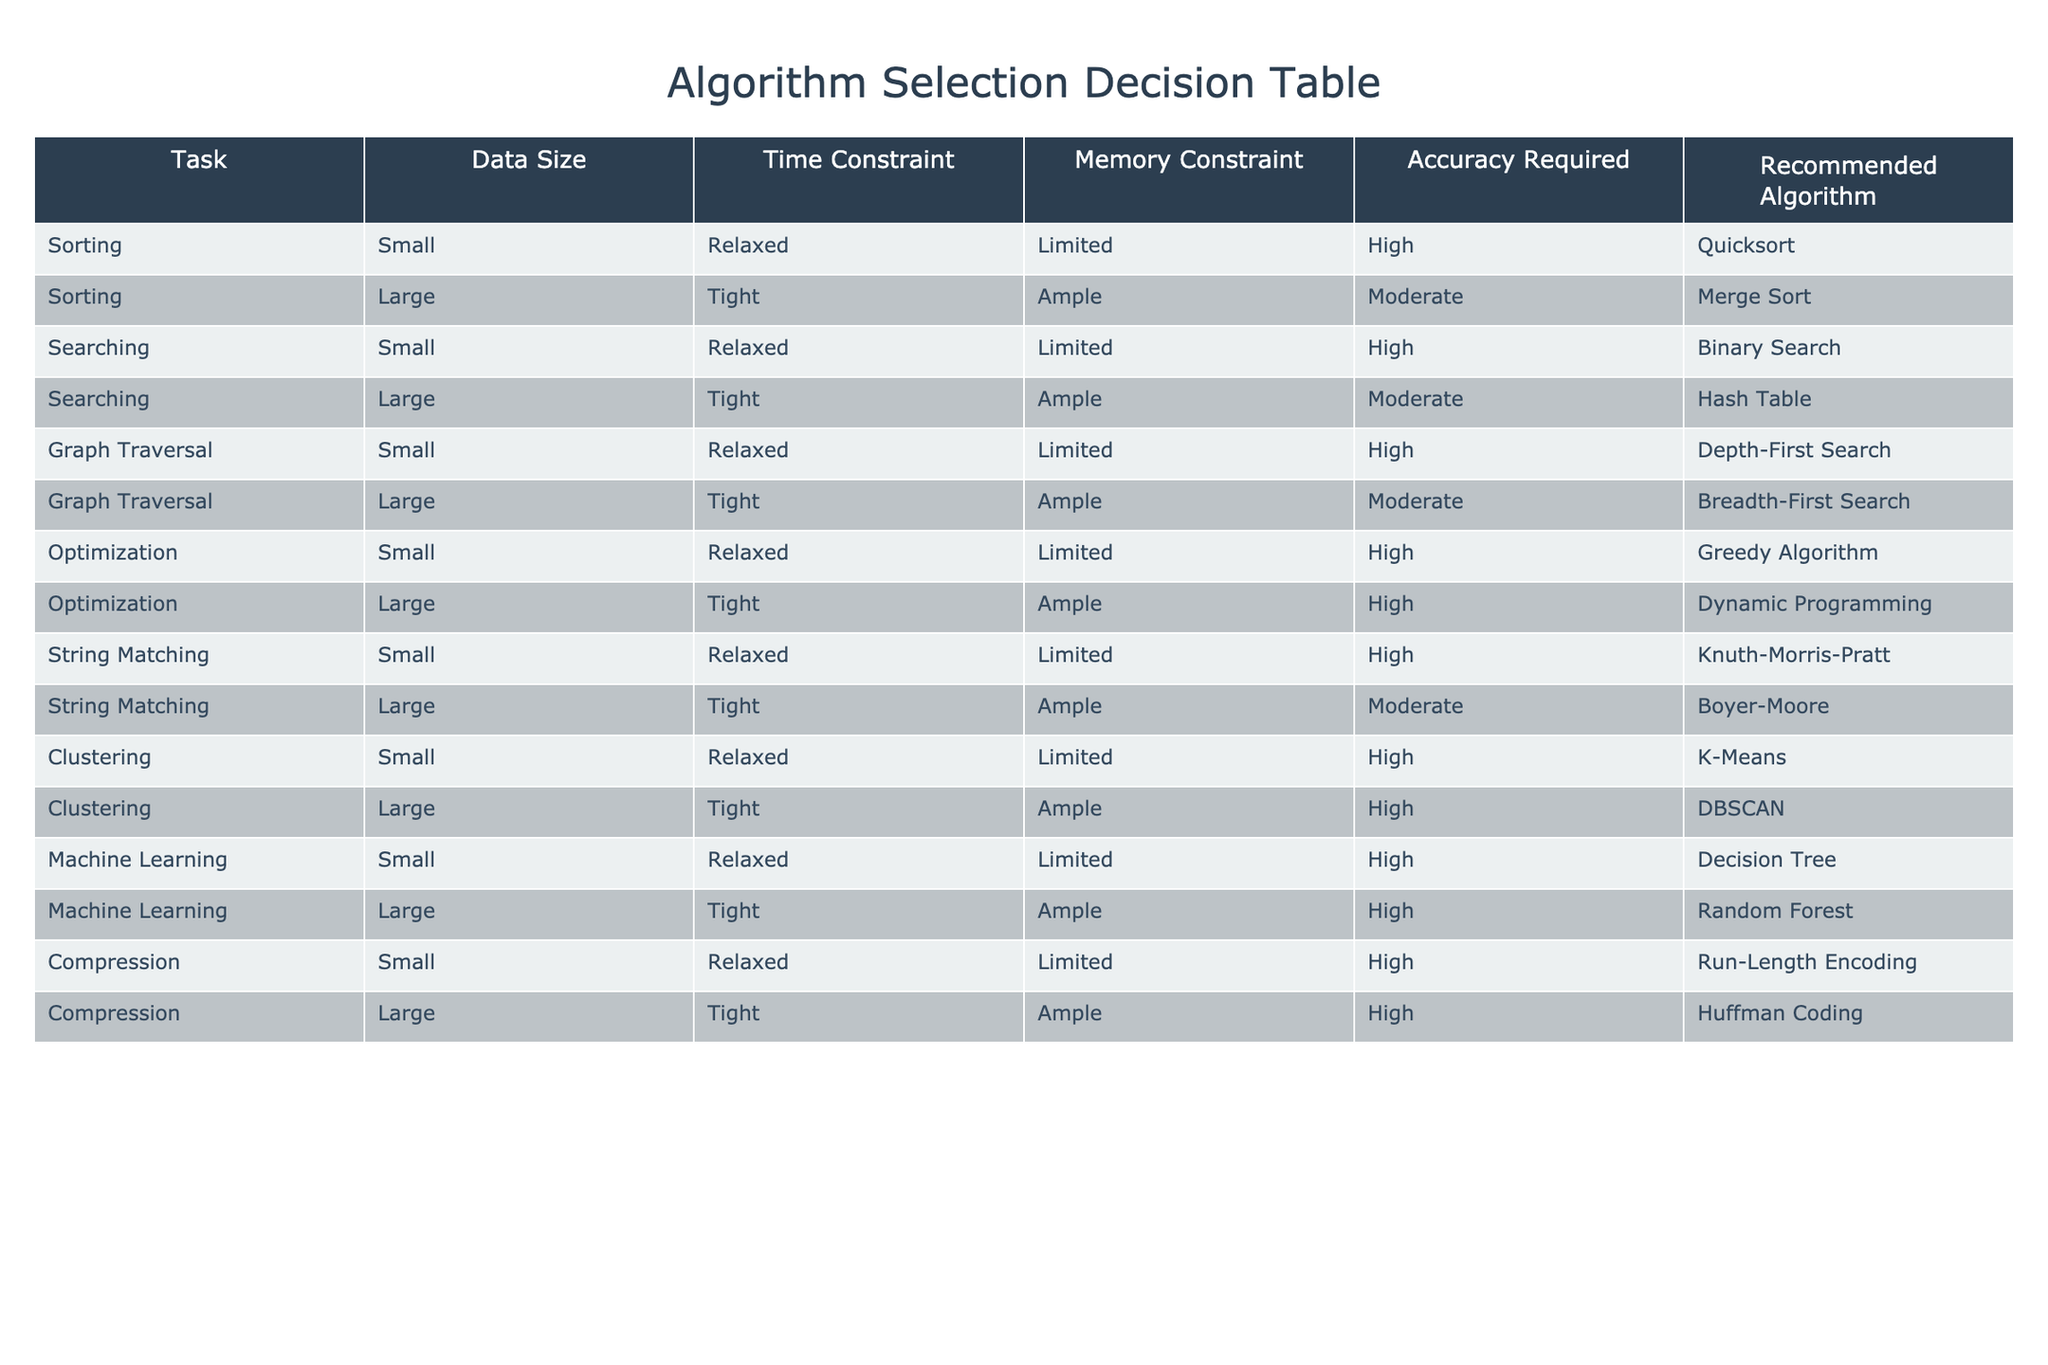What is the recommended algorithm for sorting large datasets with a tight time constraint? According to the table, the recommended algorithm for sorting large datasets when the time constraint is tight is Merge Sort.
Answer: Merge Sort Which algorithm is suggested for searching in small datasets with high accuracy requirements? The table indicates that the recommended algorithm for searching in small datasets with high accuracy requirements is Binary Search.
Answer: Binary Search Is the recommended algorithm for optimization in small datasets a Greedy Algorithm? Yes, the table confirms that the recommended algorithm for optimization in small datasets is indeed a Greedy Algorithm.
Answer: Yes For large datasets needing high accuracy and tight time constraints in clustering tasks, what is the recommended algorithm? The table shows that for clustering large datasets with high accuracy and tight time constraints, the recommended algorithm is DBSCAN. This is found in the column for clustering tasks.
Answer: DBSCAN How many algorithms are recommended for small datasets under relaxed time and memory constraints? By examining the table, we can see that there are 6 tasks listed for small datasets under relaxed time and memory constraints, each with a unique recommended algorithm. These tasks are Sorting, Graph Traversal, Optimization, String Matching, Clustering, and Machine Learning, resulting in a total of 6 algorithms.
Answer: 6 What is the recommended algorithm for compression of large datasets? The recommended algorithm for compression of large datasets, according to the table, is Huffman Coding. This information can be found in the compression row for large datasets.
Answer: Huffman Coding Is it true that Depth-First Search is the recommended algorithm for graph traversal in small datasets? Yes, based on the table, it is true that Depth-First Search is indicated as the recommended algorithm for graph traversal in small datasets.
Answer: Yes What would be the average accuracy requirement for optimization tasks across both small and large datasets? The table indicates both small and large optimization tasks require high accuracy. Therefore, combining this maximum accuracy from both groups, the average accuracy requirement remains high. There are no moderate or low values present in these rows.
Answer: High Which algorithms are suggested for string matching tasks across small and large datasets? According to the table, for small datasets, the suggested algorithm is Knuth-Morris-Pratt, while for large datasets it is Boyer-Moore. This information is combined from the respective rows associated with string matching tasks.
Answer: Knuth-Morris-Pratt and Boyer-Moore 